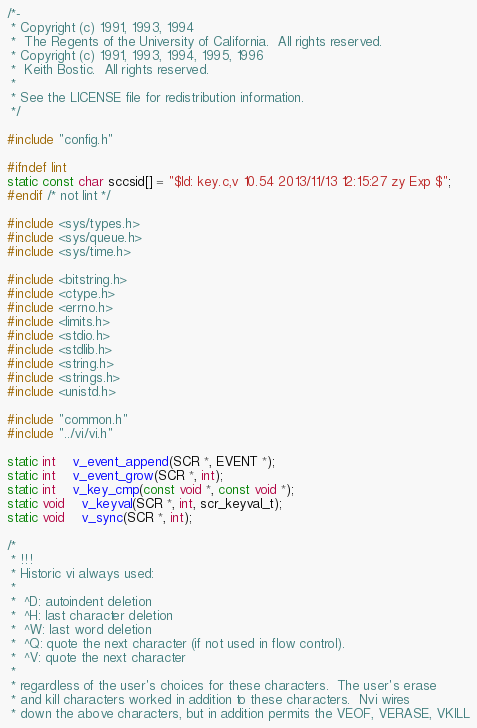Convert code to text. <code><loc_0><loc_0><loc_500><loc_500><_C_>/*-
 * Copyright (c) 1991, 1993, 1994
 *	The Regents of the University of California.  All rights reserved.
 * Copyright (c) 1991, 1993, 1994, 1995, 1996
 *	Keith Bostic.  All rights reserved.
 *
 * See the LICENSE file for redistribution information.
 */

#include "config.h"

#ifndef lint
static const char sccsid[] = "$Id: key.c,v 10.54 2013/11/13 12:15:27 zy Exp $";
#endif /* not lint */

#include <sys/types.h>
#include <sys/queue.h>
#include <sys/time.h>

#include <bitstring.h>
#include <ctype.h>
#include <errno.h>
#include <limits.h>
#include <stdio.h>
#include <stdlib.h>
#include <string.h>
#include <strings.h>
#include <unistd.h>

#include "common.h"
#include "../vi/vi.h"

static int	v_event_append(SCR *, EVENT *);
static int	v_event_grow(SCR *, int);
static int	v_key_cmp(const void *, const void *);
static void	v_keyval(SCR *, int, scr_keyval_t);
static void	v_sync(SCR *, int);

/*
 * !!!
 * Historic vi always used:
 *
 *	^D: autoindent deletion
 *	^H: last character deletion
 *	^W: last word deletion
 *	^Q: quote the next character (if not used in flow control).
 *	^V: quote the next character
 *
 * regardless of the user's choices for these characters.  The user's erase
 * and kill characters worked in addition to these characters.  Nvi wires
 * down the above characters, but in addition permits the VEOF, VERASE, VKILL</code> 